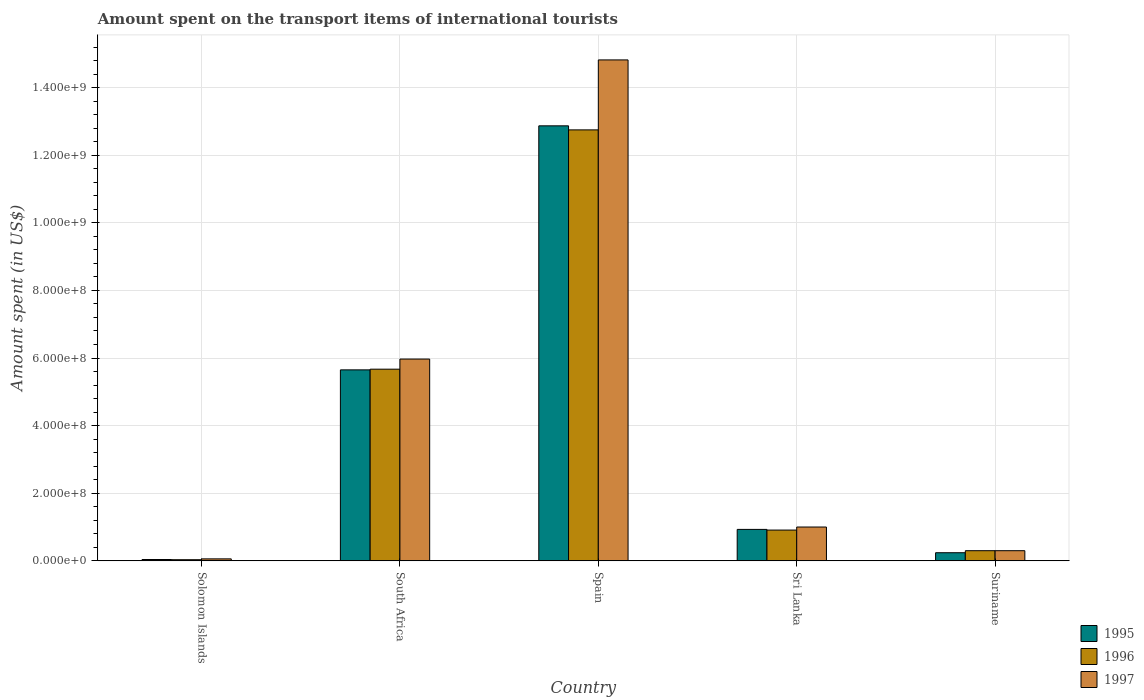How many groups of bars are there?
Give a very brief answer. 5. Are the number of bars on each tick of the X-axis equal?
Your answer should be very brief. Yes. How many bars are there on the 2nd tick from the right?
Keep it short and to the point. 3. What is the label of the 1st group of bars from the left?
Offer a terse response. Solomon Islands. What is the amount spent on the transport items of international tourists in 1997 in Sri Lanka?
Your answer should be compact. 1.00e+08. Across all countries, what is the maximum amount spent on the transport items of international tourists in 1995?
Ensure brevity in your answer.  1.29e+09. Across all countries, what is the minimum amount spent on the transport items of international tourists in 1997?
Offer a terse response. 5.80e+06. In which country was the amount spent on the transport items of international tourists in 1996 maximum?
Offer a very short reply. Spain. In which country was the amount spent on the transport items of international tourists in 1997 minimum?
Offer a very short reply. Solomon Islands. What is the total amount spent on the transport items of international tourists in 1996 in the graph?
Ensure brevity in your answer.  1.97e+09. What is the difference between the amount spent on the transport items of international tourists in 1995 in Solomon Islands and that in Sri Lanka?
Make the answer very short. -8.91e+07. What is the difference between the amount spent on the transport items of international tourists in 1996 in Sri Lanka and the amount spent on the transport items of international tourists in 1997 in Suriname?
Provide a succinct answer. 6.10e+07. What is the average amount spent on the transport items of international tourists in 1996 per country?
Give a very brief answer. 3.93e+08. What is the difference between the amount spent on the transport items of international tourists of/in 1997 and amount spent on the transport items of international tourists of/in 1995 in South Africa?
Offer a terse response. 3.20e+07. What is the ratio of the amount spent on the transport items of international tourists in 1996 in Spain to that in Suriname?
Your response must be concise. 42.5. Is the amount spent on the transport items of international tourists in 1996 in Spain less than that in Sri Lanka?
Provide a succinct answer. No. Is the difference between the amount spent on the transport items of international tourists in 1997 in Spain and Sri Lanka greater than the difference between the amount spent on the transport items of international tourists in 1995 in Spain and Sri Lanka?
Offer a very short reply. Yes. What is the difference between the highest and the second highest amount spent on the transport items of international tourists in 1997?
Keep it short and to the point. 1.38e+09. What is the difference between the highest and the lowest amount spent on the transport items of international tourists in 1997?
Keep it short and to the point. 1.48e+09. Is the sum of the amount spent on the transport items of international tourists in 1997 in Spain and Sri Lanka greater than the maximum amount spent on the transport items of international tourists in 1995 across all countries?
Make the answer very short. Yes. What does the 1st bar from the right in South Africa represents?
Your response must be concise. 1997. Are all the bars in the graph horizontal?
Your answer should be compact. No. How many countries are there in the graph?
Give a very brief answer. 5. Does the graph contain grids?
Your answer should be compact. Yes. What is the title of the graph?
Give a very brief answer. Amount spent on the transport items of international tourists. What is the label or title of the X-axis?
Provide a short and direct response. Country. What is the label or title of the Y-axis?
Provide a short and direct response. Amount spent (in US$). What is the Amount spent (in US$) of 1995 in Solomon Islands?
Provide a succinct answer. 3.90e+06. What is the Amount spent (in US$) of 1996 in Solomon Islands?
Offer a terse response. 3.30e+06. What is the Amount spent (in US$) of 1997 in Solomon Islands?
Offer a very short reply. 5.80e+06. What is the Amount spent (in US$) in 1995 in South Africa?
Offer a very short reply. 5.65e+08. What is the Amount spent (in US$) in 1996 in South Africa?
Provide a succinct answer. 5.67e+08. What is the Amount spent (in US$) in 1997 in South Africa?
Ensure brevity in your answer.  5.97e+08. What is the Amount spent (in US$) of 1995 in Spain?
Your answer should be very brief. 1.29e+09. What is the Amount spent (in US$) of 1996 in Spain?
Give a very brief answer. 1.28e+09. What is the Amount spent (in US$) of 1997 in Spain?
Ensure brevity in your answer.  1.48e+09. What is the Amount spent (in US$) in 1995 in Sri Lanka?
Your answer should be very brief. 9.30e+07. What is the Amount spent (in US$) of 1996 in Sri Lanka?
Your answer should be compact. 9.10e+07. What is the Amount spent (in US$) of 1995 in Suriname?
Provide a succinct answer. 2.40e+07. What is the Amount spent (in US$) of 1996 in Suriname?
Offer a terse response. 3.00e+07. What is the Amount spent (in US$) in 1997 in Suriname?
Offer a very short reply. 3.00e+07. Across all countries, what is the maximum Amount spent (in US$) in 1995?
Your answer should be very brief. 1.29e+09. Across all countries, what is the maximum Amount spent (in US$) in 1996?
Give a very brief answer. 1.28e+09. Across all countries, what is the maximum Amount spent (in US$) in 1997?
Give a very brief answer. 1.48e+09. Across all countries, what is the minimum Amount spent (in US$) of 1995?
Give a very brief answer. 3.90e+06. Across all countries, what is the minimum Amount spent (in US$) in 1996?
Your response must be concise. 3.30e+06. Across all countries, what is the minimum Amount spent (in US$) of 1997?
Keep it short and to the point. 5.80e+06. What is the total Amount spent (in US$) of 1995 in the graph?
Give a very brief answer. 1.97e+09. What is the total Amount spent (in US$) in 1996 in the graph?
Offer a very short reply. 1.97e+09. What is the total Amount spent (in US$) of 1997 in the graph?
Provide a succinct answer. 2.21e+09. What is the difference between the Amount spent (in US$) in 1995 in Solomon Islands and that in South Africa?
Your answer should be compact. -5.61e+08. What is the difference between the Amount spent (in US$) of 1996 in Solomon Islands and that in South Africa?
Provide a succinct answer. -5.64e+08. What is the difference between the Amount spent (in US$) in 1997 in Solomon Islands and that in South Africa?
Make the answer very short. -5.91e+08. What is the difference between the Amount spent (in US$) in 1995 in Solomon Islands and that in Spain?
Give a very brief answer. -1.28e+09. What is the difference between the Amount spent (in US$) in 1996 in Solomon Islands and that in Spain?
Provide a succinct answer. -1.27e+09. What is the difference between the Amount spent (in US$) of 1997 in Solomon Islands and that in Spain?
Offer a very short reply. -1.48e+09. What is the difference between the Amount spent (in US$) of 1995 in Solomon Islands and that in Sri Lanka?
Offer a terse response. -8.91e+07. What is the difference between the Amount spent (in US$) of 1996 in Solomon Islands and that in Sri Lanka?
Offer a terse response. -8.77e+07. What is the difference between the Amount spent (in US$) of 1997 in Solomon Islands and that in Sri Lanka?
Ensure brevity in your answer.  -9.42e+07. What is the difference between the Amount spent (in US$) of 1995 in Solomon Islands and that in Suriname?
Keep it short and to the point. -2.01e+07. What is the difference between the Amount spent (in US$) in 1996 in Solomon Islands and that in Suriname?
Offer a terse response. -2.67e+07. What is the difference between the Amount spent (in US$) in 1997 in Solomon Islands and that in Suriname?
Offer a terse response. -2.42e+07. What is the difference between the Amount spent (in US$) of 1995 in South Africa and that in Spain?
Offer a very short reply. -7.22e+08. What is the difference between the Amount spent (in US$) of 1996 in South Africa and that in Spain?
Make the answer very short. -7.08e+08. What is the difference between the Amount spent (in US$) in 1997 in South Africa and that in Spain?
Your answer should be very brief. -8.85e+08. What is the difference between the Amount spent (in US$) of 1995 in South Africa and that in Sri Lanka?
Your answer should be very brief. 4.72e+08. What is the difference between the Amount spent (in US$) in 1996 in South Africa and that in Sri Lanka?
Make the answer very short. 4.76e+08. What is the difference between the Amount spent (in US$) in 1997 in South Africa and that in Sri Lanka?
Offer a very short reply. 4.97e+08. What is the difference between the Amount spent (in US$) in 1995 in South Africa and that in Suriname?
Offer a very short reply. 5.41e+08. What is the difference between the Amount spent (in US$) in 1996 in South Africa and that in Suriname?
Give a very brief answer. 5.37e+08. What is the difference between the Amount spent (in US$) in 1997 in South Africa and that in Suriname?
Give a very brief answer. 5.67e+08. What is the difference between the Amount spent (in US$) of 1995 in Spain and that in Sri Lanka?
Provide a succinct answer. 1.19e+09. What is the difference between the Amount spent (in US$) of 1996 in Spain and that in Sri Lanka?
Provide a short and direct response. 1.18e+09. What is the difference between the Amount spent (in US$) in 1997 in Spain and that in Sri Lanka?
Your answer should be very brief. 1.38e+09. What is the difference between the Amount spent (in US$) in 1995 in Spain and that in Suriname?
Provide a succinct answer. 1.26e+09. What is the difference between the Amount spent (in US$) of 1996 in Spain and that in Suriname?
Ensure brevity in your answer.  1.24e+09. What is the difference between the Amount spent (in US$) of 1997 in Spain and that in Suriname?
Ensure brevity in your answer.  1.45e+09. What is the difference between the Amount spent (in US$) of 1995 in Sri Lanka and that in Suriname?
Offer a terse response. 6.90e+07. What is the difference between the Amount spent (in US$) of 1996 in Sri Lanka and that in Suriname?
Make the answer very short. 6.10e+07. What is the difference between the Amount spent (in US$) in 1997 in Sri Lanka and that in Suriname?
Your answer should be very brief. 7.00e+07. What is the difference between the Amount spent (in US$) in 1995 in Solomon Islands and the Amount spent (in US$) in 1996 in South Africa?
Your answer should be very brief. -5.63e+08. What is the difference between the Amount spent (in US$) in 1995 in Solomon Islands and the Amount spent (in US$) in 1997 in South Africa?
Ensure brevity in your answer.  -5.93e+08. What is the difference between the Amount spent (in US$) in 1996 in Solomon Islands and the Amount spent (in US$) in 1997 in South Africa?
Your answer should be compact. -5.94e+08. What is the difference between the Amount spent (in US$) in 1995 in Solomon Islands and the Amount spent (in US$) in 1996 in Spain?
Provide a succinct answer. -1.27e+09. What is the difference between the Amount spent (in US$) of 1995 in Solomon Islands and the Amount spent (in US$) of 1997 in Spain?
Provide a short and direct response. -1.48e+09. What is the difference between the Amount spent (in US$) in 1996 in Solomon Islands and the Amount spent (in US$) in 1997 in Spain?
Provide a short and direct response. -1.48e+09. What is the difference between the Amount spent (in US$) of 1995 in Solomon Islands and the Amount spent (in US$) of 1996 in Sri Lanka?
Ensure brevity in your answer.  -8.71e+07. What is the difference between the Amount spent (in US$) of 1995 in Solomon Islands and the Amount spent (in US$) of 1997 in Sri Lanka?
Make the answer very short. -9.61e+07. What is the difference between the Amount spent (in US$) in 1996 in Solomon Islands and the Amount spent (in US$) in 1997 in Sri Lanka?
Provide a short and direct response. -9.67e+07. What is the difference between the Amount spent (in US$) of 1995 in Solomon Islands and the Amount spent (in US$) of 1996 in Suriname?
Provide a short and direct response. -2.61e+07. What is the difference between the Amount spent (in US$) of 1995 in Solomon Islands and the Amount spent (in US$) of 1997 in Suriname?
Make the answer very short. -2.61e+07. What is the difference between the Amount spent (in US$) of 1996 in Solomon Islands and the Amount spent (in US$) of 1997 in Suriname?
Offer a very short reply. -2.67e+07. What is the difference between the Amount spent (in US$) of 1995 in South Africa and the Amount spent (in US$) of 1996 in Spain?
Your response must be concise. -7.10e+08. What is the difference between the Amount spent (in US$) in 1995 in South Africa and the Amount spent (in US$) in 1997 in Spain?
Make the answer very short. -9.17e+08. What is the difference between the Amount spent (in US$) in 1996 in South Africa and the Amount spent (in US$) in 1997 in Spain?
Your answer should be very brief. -9.15e+08. What is the difference between the Amount spent (in US$) in 1995 in South Africa and the Amount spent (in US$) in 1996 in Sri Lanka?
Offer a terse response. 4.74e+08. What is the difference between the Amount spent (in US$) of 1995 in South Africa and the Amount spent (in US$) of 1997 in Sri Lanka?
Offer a very short reply. 4.65e+08. What is the difference between the Amount spent (in US$) of 1996 in South Africa and the Amount spent (in US$) of 1997 in Sri Lanka?
Give a very brief answer. 4.67e+08. What is the difference between the Amount spent (in US$) in 1995 in South Africa and the Amount spent (in US$) in 1996 in Suriname?
Provide a succinct answer. 5.35e+08. What is the difference between the Amount spent (in US$) of 1995 in South Africa and the Amount spent (in US$) of 1997 in Suriname?
Provide a succinct answer. 5.35e+08. What is the difference between the Amount spent (in US$) of 1996 in South Africa and the Amount spent (in US$) of 1997 in Suriname?
Offer a terse response. 5.37e+08. What is the difference between the Amount spent (in US$) of 1995 in Spain and the Amount spent (in US$) of 1996 in Sri Lanka?
Give a very brief answer. 1.20e+09. What is the difference between the Amount spent (in US$) in 1995 in Spain and the Amount spent (in US$) in 1997 in Sri Lanka?
Your answer should be compact. 1.19e+09. What is the difference between the Amount spent (in US$) of 1996 in Spain and the Amount spent (in US$) of 1997 in Sri Lanka?
Keep it short and to the point. 1.18e+09. What is the difference between the Amount spent (in US$) of 1995 in Spain and the Amount spent (in US$) of 1996 in Suriname?
Offer a terse response. 1.26e+09. What is the difference between the Amount spent (in US$) in 1995 in Spain and the Amount spent (in US$) in 1997 in Suriname?
Keep it short and to the point. 1.26e+09. What is the difference between the Amount spent (in US$) in 1996 in Spain and the Amount spent (in US$) in 1997 in Suriname?
Your response must be concise. 1.24e+09. What is the difference between the Amount spent (in US$) in 1995 in Sri Lanka and the Amount spent (in US$) in 1996 in Suriname?
Offer a very short reply. 6.30e+07. What is the difference between the Amount spent (in US$) of 1995 in Sri Lanka and the Amount spent (in US$) of 1997 in Suriname?
Make the answer very short. 6.30e+07. What is the difference between the Amount spent (in US$) in 1996 in Sri Lanka and the Amount spent (in US$) in 1997 in Suriname?
Provide a short and direct response. 6.10e+07. What is the average Amount spent (in US$) of 1995 per country?
Offer a terse response. 3.95e+08. What is the average Amount spent (in US$) in 1996 per country?
Your answer should be compact. 3.93e+08. What is the average Amount spent (in US$) in 1997 per country?
Make the answer very short. 4.43e+08. What is the difference between the Amount spent (in US$) in 1995 and Amount spent (in US$) in 1996 in Solomon Islands?
Provide a succinct answer. 6.00e+05. What is the difference between the Amount spent (in US$) in 1995 and Amount spent (in US$) in 1997 in Solomon Islands?
Offer a terse response. -1.90e+06. What is the difference between the Amount spent (in US$) in 1996 and Amount spent (in US$) in 1997 in Solomon Islands?
Your answer should be compact. -2.50e+06. What is the difference between the Amount spent (in US$) in 1995 and Amount spent (in US$) in 1996 in South Africa?
Your answer should be very brief. -2.00e+06. What is the difference between the Amount spent (in US$) in 1995 and Amount spent (in US$) in 1997 in South Africa?
Ensure brevity in your answer.  -3.20e+07. What is the difference between the Amount spent (in US$) of 1996 and Amount spent (in US$) of 1997 in South Africa?
Ensure brevity in your answer.  -3.00e+07. What is the difference between the Amount spent (in US$) of 1995 and Amount spent (in US$) of 1996 in Spain?
Your answer should be compact. 1.20e+07. What is the difference between the Amount spent (in US$) of 1995 and Amount spent (in US$) of 1997 in Spain?
Give a very brief answer. -1.95e+08. What is the difference between the Amount spent (in US$) of 1996 and Amount spent (in US$) of 1997 in Spain?
Ensure brevity in your answer.  -2.07e+08. What is the difference between the Amount spent (in US$) of 1995 and Amount spent (in US$) of 1996 in Sri Lanka?
Give a very brief answer. 2.00e+06. What is the difference between the Amount spent (in US$) in 1995 and Amount spent (in US$) in 1997 in Sri Lanka?
Make the answer very short. -7.00e+06. What is the difference between the Amount spent (in US$) in 1996 and Amount spent (in US$) in 1997 in Sri Lanka?
Your answer should be very brief. -9.00e+06. What is the difference between the Amount spent (in US$) of 1995 and Amount spent (in US$) of 1996 in Suriname?
Your answer should be very brief. -6.00e+06. What is the difference between the Amount spent (in US$) of 1995 and Amount spent (in US$) of 1997 in Suriname?
Your answer should be compact. -6.00e+06. What is the difference between the Amount spent (in US$) in 1996 and Amount spent (in US$) in 1997 in Suriname?
Offer a terse response. 0. What is the ratio of the Amount spent (in US$) in 1995 in Solomon Islands to that in South Africa?
Keep it short and to the point. 0.01. What is the ratio of the Amount spent (in US$) of 1996 in Solomon Islands to that in South Africa?
Make the answer very short. 0.01. What is the ratio of the Amount spent (in US$) in 1997 in Solomon Islands to that in South Africa?
Keep it short and to the point. 0.01. What is the ratio of the Amount spent (in US$) of 1995 in Solomon Islands to that in Spain?
Provide a short and direct response. 0. What is the ratio of the Amount spent (in US$) of 1996 in Solomon Islands to that in Spain?
Provide a succinct answer. 0. What is the ratio of the Amount spent (in US$) in 1997 in Solomon Islands to that in Spain?
Provide a succinct answer. 0. What is the ratio of the Amount spent (in US$) in 1995 in Solomon Islands to that in Sri Lanka?
Your response must be concise. 0.04. What is the ratio of the Amount spent (in US$) in 1996 in Solomon Islands to that in Sri Lanka?
Provide a short and direct response. 0.04. What is the ratio of the Amount spent (in US$) of 1997 in Solomon Islands to that in Sri Lanka?
Keep it short and to the point. 0.06. What is the ratio of the Amount spent (in US$) in 1995 in Solomon Islands to that in Suriname?
Make the answer very short. 0.16. What is the ratio of the Amount spent (in US$) in 1996 in Solomon Islands to that in Suriname?
Provide a succinct answer. 0.11. What is the ratio of the Amount spent (in US$) in 1997 in Solomon Islands to that in Suriname?
Your answer should be very brief. 0.19. What is the ratio of the Amount spent (in US$) of 1995 in South Africa to that in Spain?
Make the answer very short. 0.44. What is the ratio of the Amount spent (in US$) of 1996 in South Africa to that in Spain?
Give a very brief answer. 0.44. What is the ratio of the Amount spent (in US$) in 1997 in South Africa to that in Spain?
Provide a short and direct response. 0.4. What is the ratio of the Amount spent (in US$) of 1995 in South Africa to that in Sri Lanka?
Ensure brevity in your answer.  6.08. What is the ratio of the Amount spent (in US$) of 1996 in South Africa to that in Sri Lanka?
Ensure brevity in your answer.  6.23. What is the ratio of the Amount spent (in US$) of 1997 in South Africa to that in Sri Lanka?
Ensure brevity in your answer.  5.97. What is the ratio of the Amount spent (in US$) in 1995 in South Africa to that in Suriname?
Keep it short and to the point. 23.54. What is the ratio of the Amount spent (in US$) in 1995 in Spain to that in Sri Lanka?
Provide a short and direct response. 13.84. What is the ratio of the Amount spent (in US$) in 1996 in Spain to that in Sri Lanka?
Make the answer very short. 14.01. What is the ratio of the Amount spent (in US$) in 1997 in Spain to that in Sri Lanka?
Offer a terse response. 14.82. What is the ratio of the Amount spent (in US$) of 1995 in Spain to that in Suriname?
Provide a succinct answer. 53.62. What is the ratio of the Amount spent (in US$) in 1996 in Spain to that in Suriname?
Give a very brief answer. 42.5. What is the ratio of the Amount spent (in US$) of 1997 in Spain to that in Suriname?
Make the answer very short. 49.4. What is the ratio of the Amount spent (in US$) in 1995 in Sri Lanka to that in Suriname?
Make the answer very short. 3.88. What is the ratio of the Amount spent (in US$) in 1996 in Sri Lanka to that in Suriname?
Ensure brevity in your answer.  3.03. What is the difference between the highest and the second highest Amount spent (in US$) of 1995?
Ensure brevity in your answer.  7.22e+08. What is the difference between the highest and the second highest Amount spent (in US$) of 1996?
Give a very brief answer. 7.08e+08. What is the difference between the highest and the second highest Amount spent (in US$) in 1997?
Your response must be concise. 8.85e+08. What is the difference between the highest and the lowest Amount spent (in US$) in 1995?
Your answer should be compact. 1.28e+09. What is the difference between the highest and the lowest Amount spent (in US$) of 1996?
Your response must be concise. 1.27e+09. What is the difference between the highest and the lowest Amount spent (in US$) in 1997?
Offer a terse response. 1.48e+09. 